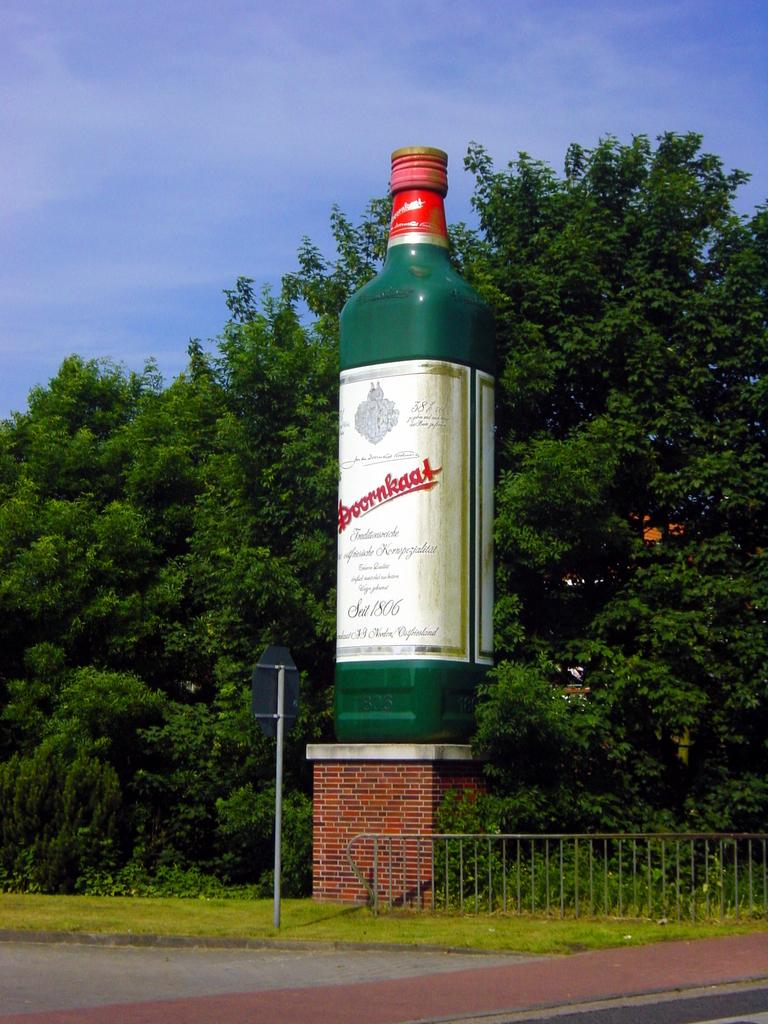<image>
Present a compact description of the photo's key features. a large green and red bottle of Doornkaat on an outside pedastal 